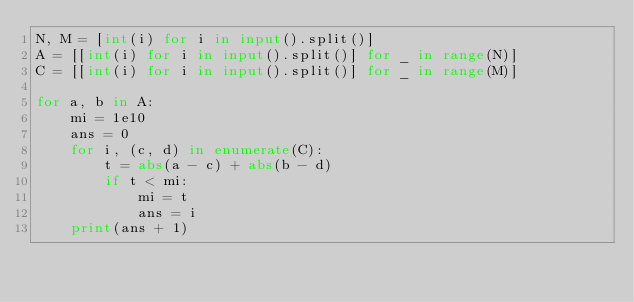<code> <loc_0><loc_0><loc_500><loc_500><_Python_>N, M = [int(i) for i in input().split()]
A = [[int(i) for i in input().split()] for _ in range(N)]
C = [[int(i) for i in input().split()] for _ in range(M)]

for a, b in A:
    mi = 1e10
    ans = 0
    for i, (c, d) in enumerate(C):
        t = abs(a - c) + abs(b - d)
        if t < mi:
            mi = t
            ans = i
    print(ans + 1)</code> 